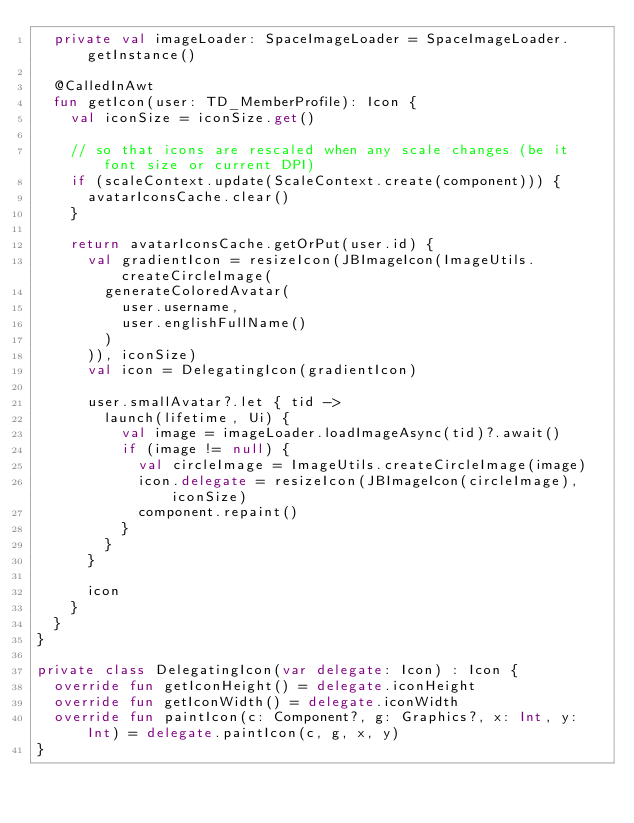Convert code to text. <code><loc_0><loc_0><loc_500><loc_500><_Kotlin_>  private val imageLoader: SpaceImageLoader = SpaceImageLoader.getInstance()

  @CalledInAwt
  fun getIcon(user: TD_MemberProfile): Icon {
    val iconSize = iconSize.get()

    // so that icons are rescaled when any scale changes (be it font size or current DPI)
    if (scaleContext.update(ScaleContext.create(component))) {
      avatarIconsCache.clear()
    }

    return avatarIconsCache.getOrPut(user.id) {
      val gradientIcon = resizeIcon(JBImageIcon(ImageUtils.createCircleImage(
        generateColoredAvatar(
          user.username,
          user.englishFullName()
        )
      )), iconSize)
      val icon = DelegatingIcon(gradientIcon)

      user.smallAvatar?.let { tid ->
        launch(lifetime, Ui) {
          val image = imageLoader.loadImageAsync(tid)?.await()
          if (image != null) {
            val circleImage = ImageUtils.createCircleImage(image)
            icon.delegate = resizeIcon(JBImageIcon(circleImage), iconSize)
            component.repaint()
          }
        }
      }

      icon
    }
  }
}

private class DelegatingIcon(var delegate: Icon) : Icon {
  override fun getIconHeight() = delegate.iconHeight
  override fun getIconWidth() = delegate.iconWidth
  override fun paintIcon(c: Component?, g: Graphics?, x: Int, y: Int) = delegate.paintIcon(c, g, x, y)
}
</code> 